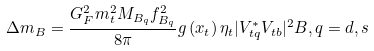Convert formula to latex. <formula><loc_0><loc_0><loc_500><loc_500>\Delta m _ { B } = \frac { G ^ { 2 } _ { F } m ^ { 2 } _ { t } M _ { B _ { q } } f ^ { 2 } _ { B _ { q } } } { 8 \pi } g \left ( x _ { t } \right ) \eta _ { t } | V ^ { * } _ { t q } V _ { t b } | ^ { 2 } B , q = d , s</formula> 